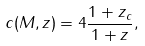Convert formula to latex. <formula><loc_0><loc_0><loc_500><loc_500>c ( M , z ) = 4 \frac { 1 + z _ { c } } { 1 + z } ,</formula> 